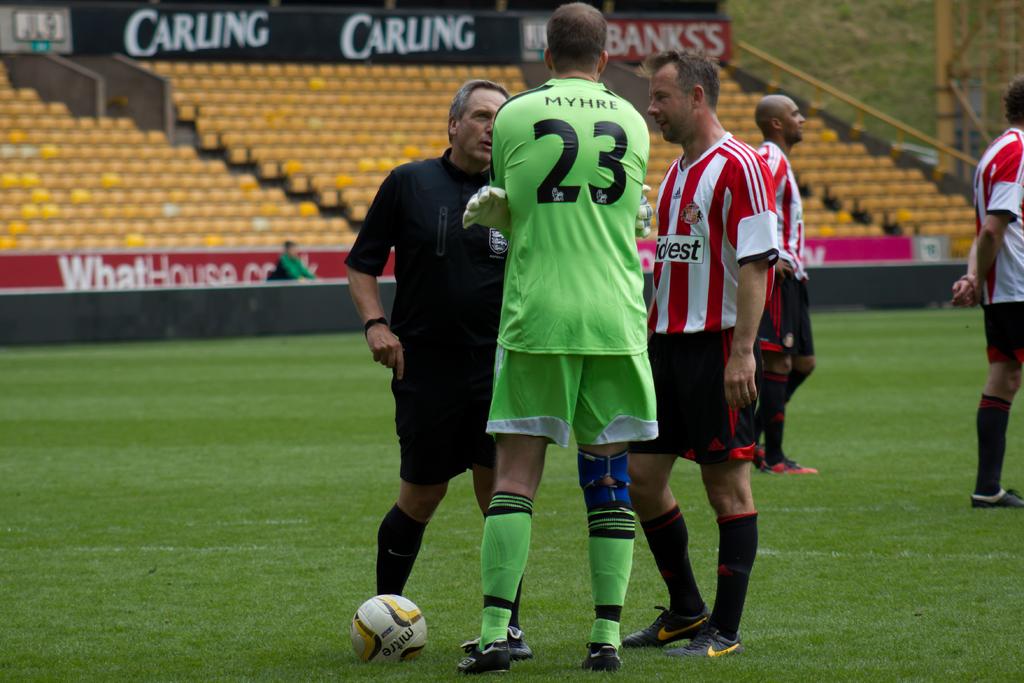What is the number of the player in green?
Give a very brief answer. 23. What is the name above 23?
Give a very brief answer. Myhre. 